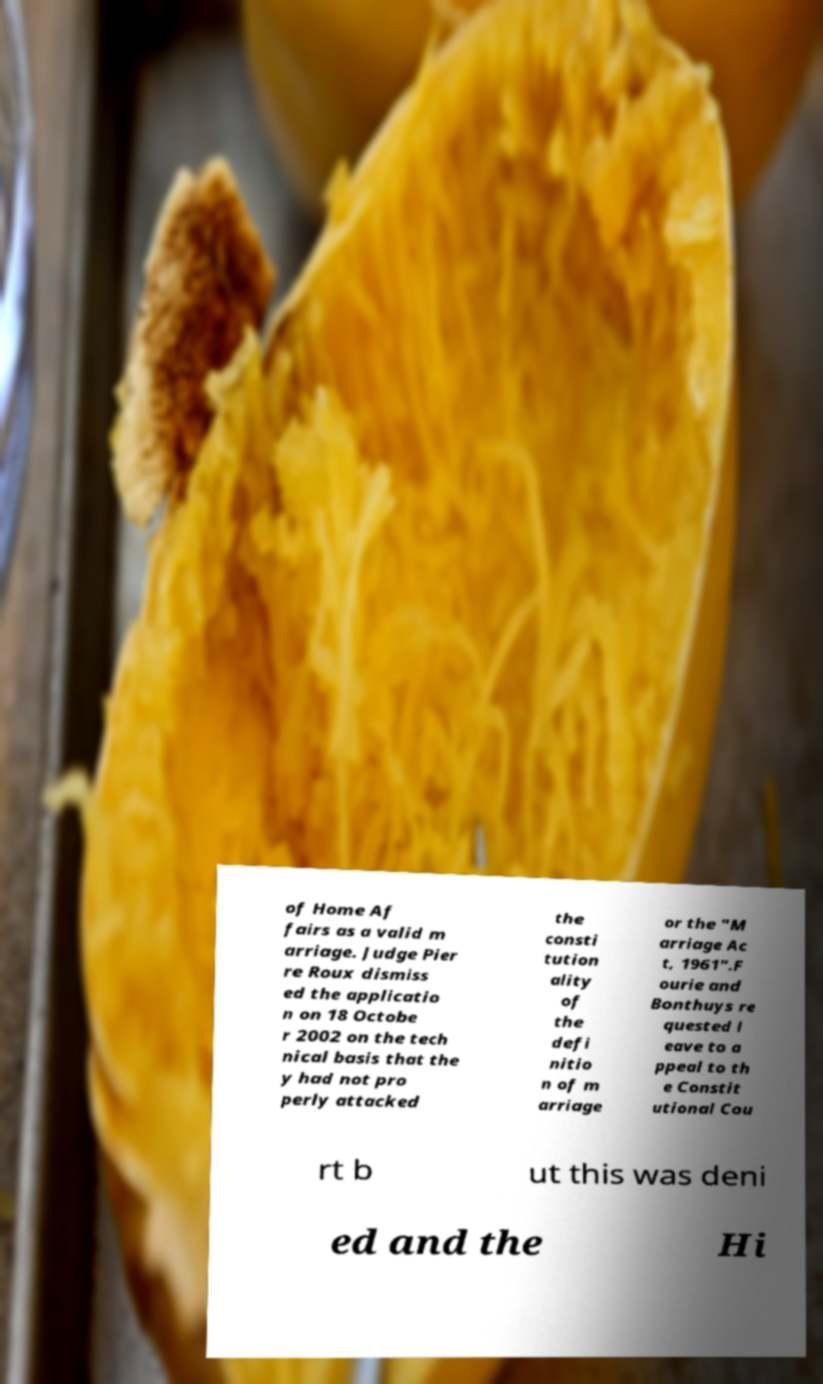Please identify and transcribe the text found in this image. of Home Af fairs as a valid m arriage. Judge Pier re Roux dismiss ed the applicatio n on 18 Octobe r 2002 on the tech nical basis that the y had not pro perly attacked the consti tution ality of the defi nitio n of m arriage or the "M arriage Ac t, 1961".F ourie and Bonthuys re quested l eave to a ppeal to th e Constit utional Cou rt b ut this was deni ed and the Hi 